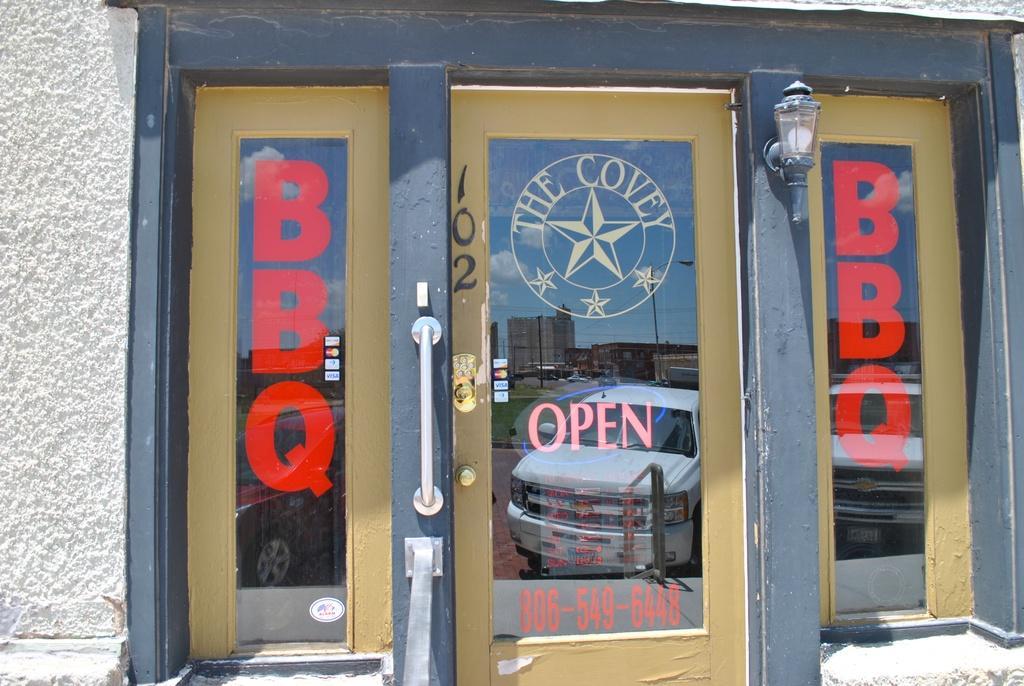Please provide a concise description of this image. In this image we can see lights, doors and windows to the building. 